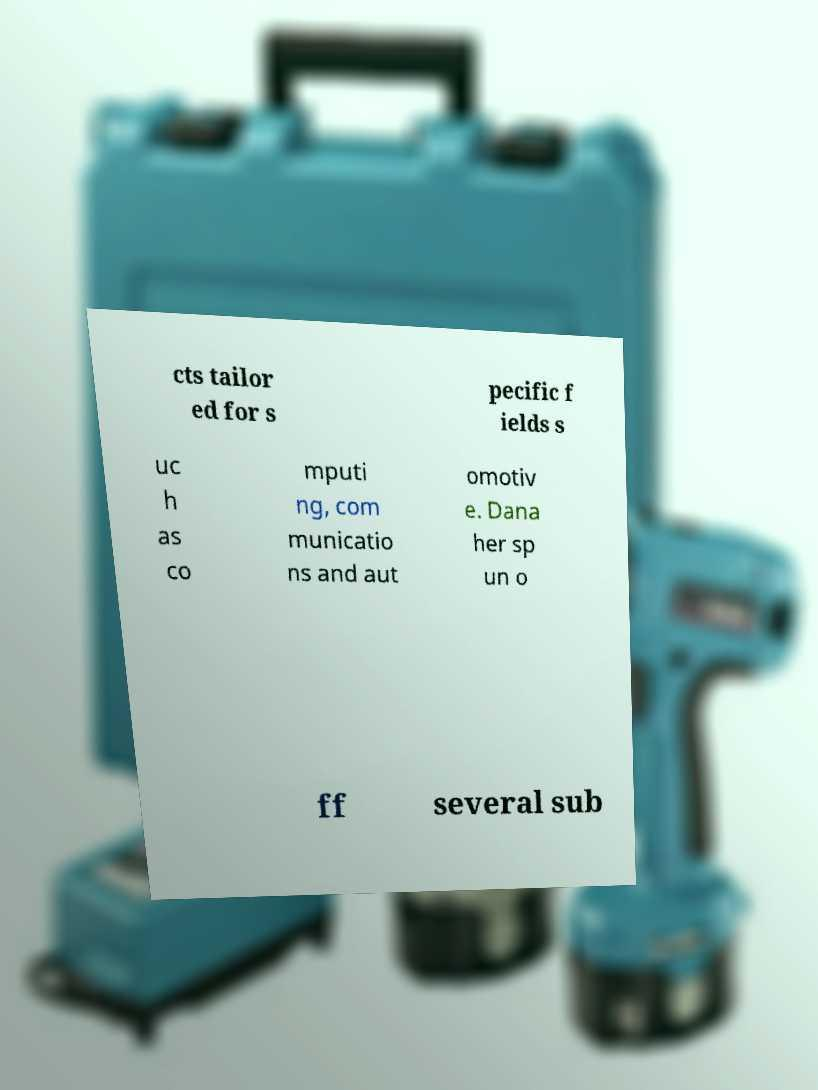Can you read and provide the text displayed in the image?This photo seems to have some interesting text. Can you extract and type it out for me? cts tailor ed for s pecific f ields s uc h as co mputi ng, com municatio ns and aut omotiv e. Dana her sp un o ff several sub 